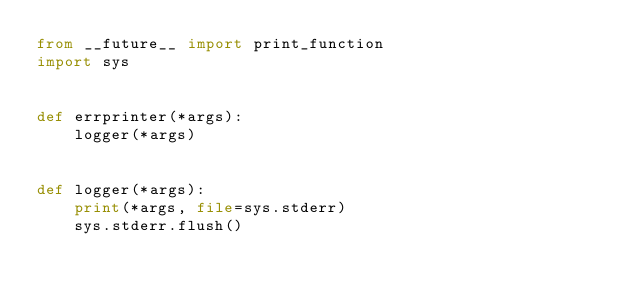Convert code to text. <code><loc_0><loc_0><loc_500><loc_500><_Python_>from __future__ import print_function
import sys


def errprinter(*args):
    logger(*args)


def logger(*args):
    print(*args, file=sys.stderr)
    sys.stderr.flush()
</code> 